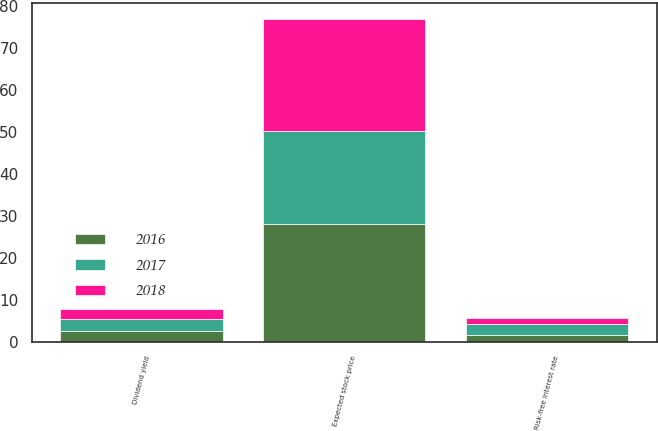Convert chart to OTSL. <chart><loc_0><loc_0><loc_500><loc_500><stacked_bar_chart><ecel><fcel>Dividend yield<fcel>Risk-free interest rate<fcel>Expected stock price<nl><fcel>2017<fcel>2.85<fcel>2.48<fcel>22<nl><fcel>2016<fcel>2.51<fcel>1.73<fcel>28.1<nl><fcel>2018<fcel>2.37<fcel>1.57<fcel>26.76<nl></chart> 